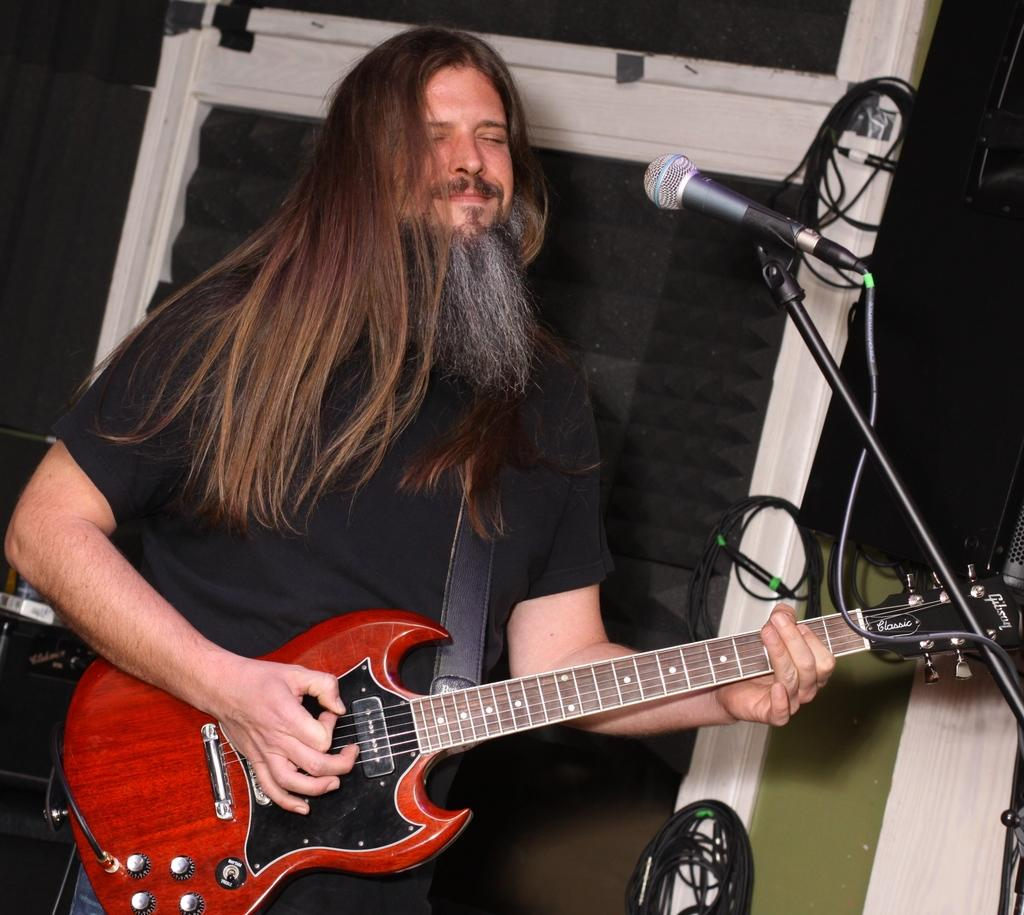Who is the main subject in the image? There is a man in the image. What is the man wearing? The man is wearing a black t-shirt. What is the man holding in the image? The man is holding a guitar. What object is in front of the man? There is a microphone with a stand in front of the man. What can be seen behind the man? There is a wall behind the man. What type of gate can be seen in the image? There is no gate present in the image. What operation is the man performing on the guitar in the image? The image does not show the man performing any operation on the guitar; he is simply holding it. 